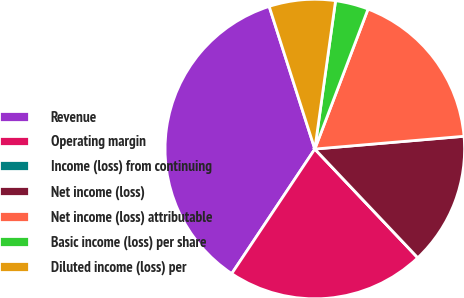Convert chart. <chart><loc_0><loc_0><loc_500><loc_500><pie_chart><fcel>Revenue<fcel>Operating margin<fcel>Income (loss) from continuing<fcel>Net income (loss)<fcel>Net income (loss) attributable<fcel>Basic income (loss) per share<fcel>Diluted income (loss) per<nl><fcel>35.71%<fcel>21.43%<fcel>0.0%<fcel>14.29%<fcel>17.86%<fcel>3.57%<fcel>7.14%<nl></chart> 